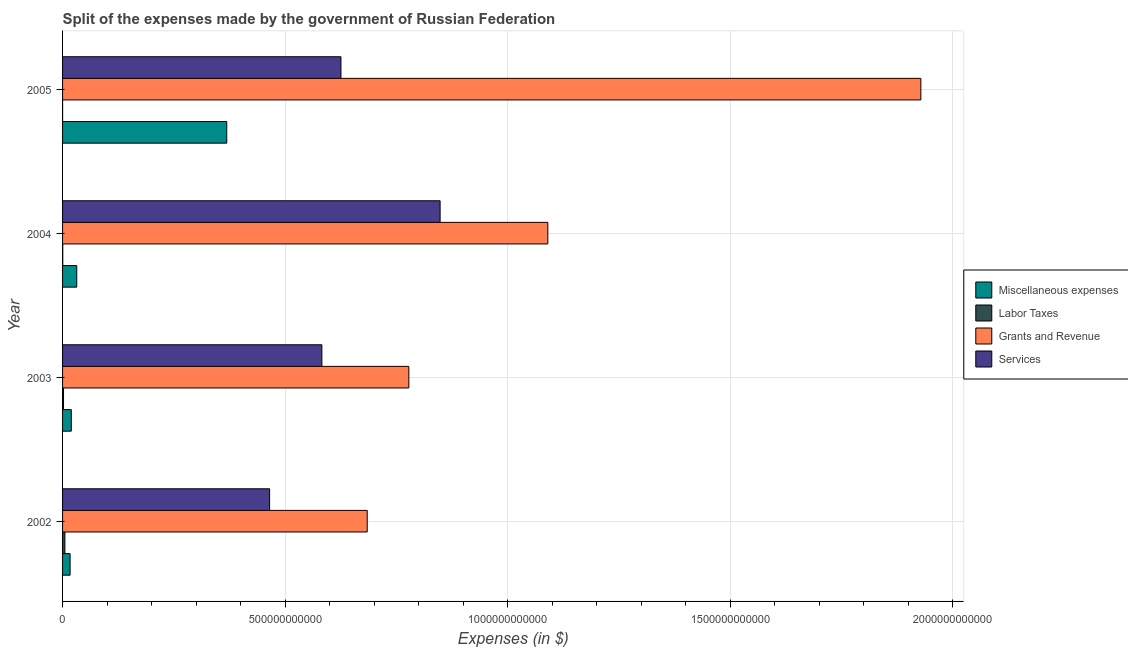How many different coloured bars are there?
Keep it short and to the point. 4. Are the number of bars per tick equal to the number of legend labels?
Your answer should be very brief. Yes. In how many cases, is the number of bars for a given year not equal to the number of legend labels?
Ensure brevity in your answer.  0. What is the amount spent on grants and revenue in 2004?
Offer a very short reply. 1.09e+12. Across all years, what is the maximum amount spent on services?
Provide a succinct answer. 8.48e+11. Across all years, what is the minimum amount spent on miscellaneous expenses?
Offer a very short reply. 1.69e+1. In which year was the amount spent on services maximum?
Provide a succinct answer. 2004. What is the total amount spent on miscellaneous expenses in the graph?
Keep it short and to the point. 4.37e+11. What is the difference between the amount spent on grants and revenue in 2002 and that in 2003?
Keep it short and to the point. -9.35e+1. What is the difference between the amount spent on grants and revenue in 2002 and the amount spent on services in 2005?
Provide a short and direct response. 5.90e+1. What is the average amount spent on miscellaneous expenses per year?
Keep it short and to the point. 1.09e+11. In the year 2002, what is the difference between the amount spent on miscellaneous expenses and amount spent on grants and revenue?
Give a very brief answer. -6.68e+11. In how many years, is the amount spent on labor taxes greater than 1600000000000 $?
Give a very brief answer. 0. What is the ratio of the amount spent on miscellaneous expenses in 2002 to that in 2003?
Ensure brevity in your answer.  0.86. Is the difference between the amount spent on labor taxes in 2002 and 2004 greater than the difference between the amount spent on services in 2002 and 2004?
Keep it short and to the point. Yes. What is the difference between the highest and the second highest amount spent on grants and revenue?
Make the answer very short. 8.38e+11. What is the difference between the highest and the lowest amount spent on services?
Your response must be concise. 3.83e+11. What does the 2nd bar from the top in 2002 represents?
Your response must be concise. Grants and Revenue. What does the 3rd bar from the bottom in 2003 represents?
Give a very brief answer. Grants and Revenue. Is it the case that in every year, the sum of the amount spent on miscellaneous expenses and amount spent on labor taxes is greater than the amount spent on grants and revenue?
Make the answer very short. No. How many bars are there?
Keep it short and to the point. 16. Are all the bars in the graph horizontal?
Make the answer very short. Yes. How many years are there in the graph?
Provide a succinct answer. 4. What is the difference between two consecutive major ticks on the X-axis?
Make the answer very short. 5.00e+11. Are the values on the major ticks of X-axis written in scientific E-notation?
Make the answer very short. No. Does the graph contain grids?
Make the answer very short. Yes. How are the legend labels stacked?
Keep it short and to the point. Vertical. What is the title of the graph?
Offer a very short reply. Split of the expenses made by the government of Russian Federation. Does "Quality of logistic services" appear as one of the legend labels in the graph?
Your answer should be compact. No. What is the label or title of the X-axis?
Ensure brevity in your answer.  Expenses (in $). What is the Expenses (in $) in Miscellaneous expenses in 2002?
Your response must be concise. 1.69e+1. What is the Expenses (in $) in Labor Taxes in 2002?
Your answer should be compact. 5.26e+09. What is the Expenses (in $) in Grants and Revenue in 2002?
Make the answer very short. 6.85e+11. What is the Expenses (in $) of Services in 2002?
Keep it short and to the point. 4.65e+11. What is the Expenses (in $) of Miscellaneous expenses in 2003?
Your answer should be very brief. 1.96e+1. What is the Expenses (in $) in Labor Taxes in 2003?
Your answer should be compact. 2.17e+09. What is the Expenses (in $) of Grants and Revenue in 2003?
Offer a terse response. 7.78e+11. What is the Expenses (in $) in Services in 2003?
Your answer should be very brief. 5.83e+11. What is the Expenses (in $) of Miscellaneous expenses in 2004?
Offer a very short reply. 3.19e+1. What is the Expenses (in $) of Labor Taxes in 2004?
Your response must be concise. 4.01e+08. What is the Expenses (in $) in Grants and Revenue in 2004?
Your response must be concise. 1.09e+12. What is the Expenses (in $) in Services in 2004?
Provide a short and direct response. 8.48e+11. What is the Expenses (in $) of Miscellaneous expenses in 2005?
Your response must be concise. 3.69e+11. What is the Expenses (in $) in Labor Taxes in 2005?
Keep it short and to the point. 7.50e+07. What is the Expenses (in $) in Grants and Revenue in 2005?
Your answer should be compact. 1.93e+12. What is the Expenses (in $) of Services in 2005?
Keep it short and to the point. 6.26e+11. Across all years, what is the maximum Expenses (in $) in Miscellaneous expenses?
Give a very brief answer. 3.69e+11. Across all years, what is the maximum Expenses (in $) of Labor Taxes?
Make the answer very short. 5.26e+09. Across all years, what is the maximum Expenses (in $) in Grants and Revenue?
Make the answer very short. 1.93e+12. Across all years, what is the maximum Expenses (in $) in Services?
Offer a very short reply. 8.48e+11. Across all years, what is the minimum Expenses (in $) of Miscellaneous expenses?
Ensure brevity in your answer.  1.69e+1. Across all years, what is the minimum Expenses (in $) in Labor Taxes?
Offer a very short reply. 7.50e+07. Across all years, what is the minimum Expenses (in $) in Grants and Revenue?
Keep it short and to the point. 6.85e+11. Across all years, what is the minimum Expenses (in $) of Services?
Offer a terse response. 4.65e+11. What is the total Expenses (in $) in Miscellaneous expenses in the graph?
Your answer should be compact. 4.37e+11. What is the total Expenses (in $) of Labor Taxes in the graph?
Give a very brief answer. 7.90e+09. What is the total Expenses (in $) in Grants and Revenue in the graph?
Make the answer very short. 4.48e+12. What is the total Expenses (in $) in Services in the graph?
Your answer should be very brief. 2.52e+12. What is the difference between the Expenses (in $) of Miscellaneous expenses in 2002 and that in 2003?
Offer a terse response. -2.72e+09. What is the difference between the Expenses (in $) in Labor Taxes in 2002 and that in 2003?
Make the answer very short. 3.09e+09. What is the difference between the Expenses (in $) in Grants and Revenue in 2002 and that in 2003?
Your answer should be very brief. -9.35e+1. What is the difference between the Expenses (in $) of Services in 2002 and that in 2003?
Provide a succinct answer. -1.17e+11. What is the difference between the Expenses (in $) of Miscellaneous expenses in 2002 and that in 2004?
Make the answer very short. -1.49e+1. What is the difference between the Expenses (in $) in Labor Taxes in 2002 and that in 2004?
Ensure brevity in your answer.  4.86e+09. What is the difference between the Expenses (in $) in Grants and Revenue in 2002 and that in 2004?
Make the answer very short. -4.06e+11. What is the difference between the Expenses (in $) in Services in 2002 and that in 2004?
Make the answer very short. -3.83e+11. What is the difference between the Expenses (in $) of Miscellaneous expenses in 2002 and that in 2005?
Offer a very short reply. -3.52e+11. What is the difference between the Expenses (in $) of Labor Taxes in 2002 and that in 2005?
Give a very brief answer. 5.18e+09. What is the difference between the Expenses (in $) in Grants and Revenue in 2002 and that in 2005?
Provide a short and direct response. -1.24e+12. What is the difference between the Expenses (in $) of Services in 2002 and that in 2005?
Offer a terse response. -1.60e+11. What is the difference between the Expenses (in $) in Miscellaneous expenses in 2003 and that in 2004?
Your answer should be very brief. -1.22e+1. What is the difference between the Expenses (in $) in Labor Taxes in 2003 and that in 2004?
Keep it short and to the point. 1.77e+09. What is the difference between the Expenses (in $) of Grants and Revenue in 2003 and that in 2004?
Your answer should be compact. -3.12e+11. What is the difference between the Expenses (in $) of Services in 2003 and that in 2004?
Provide a short and direct response. -2.66e+11. What is the difference between the Expenses (in $) of Miscellaneous expenses in 2003 and that in 2005?
Offer a very short reply. -3.49e+11. What is the difference between the Expenses (in $) in Labor Taxes in 2003 and that in 2005?
Ensure brevity in your answer.  2.09e+09. What is the difference between the Expenses (in $) in Grants and Revenue in 2003 and that in 2005?
Provide a succinct answer. -1.15e+12. What is the difference between the Expenses (in $) of Services in 2003 and that in 2005?
Your response must be concise. -4.29e+1. What is the difference between the Expenses (in $) of Miscellaneous expenses in 2004 and that in 2005?
Offer a very short reply. -3.37e+11. What is the difference between the Expenses (in $) of Labor Taxes in 2004 and that in 2005?
Give a very brief answer. 3.26e+08. What is the difference between the Expenses (in $) in Grants and Revenue in 2004 and that in 2005?
Offer a terse response. -8.38e+11. What is the difference between the Expenses (in $) of Services in 2004 and that in 2005?
Offer a terse response. 2.23e+11. What is the difference between the Expenses (in $) of Miscellaneous expenses in 2002 and the Expenses (in $) of Labor Taxes in 2003?
Provide a succinct answer. 1.47e+1. What is the difference between the Expenses (in $) of Miscellaneous expenses in 2002 and the Expenses (in $) of Grants and Revenue in 2003?
Offer a terse response. -7.61e+11. What is the difference between the Expenses (in $) in Miscellaneous expenses in 2002 and the Expenses (in $) in Services in 2003?
Offer a very short reply. -5.66e+11. What is the difference between the Expenses (in $) of Labor Taxes in 2002 and the Expenses (in $) of Grants and Revenue in 2003?
Offer a terse response. -7.73e+11. What is the difference between the Expenses (in $) in Labor Taxes in 2002 and the Expenses (in $) in Services in 2003?
Make the answer very short. -5.77e+11. What is the difference between the Expenses (in $) in Grants and Revenue in 2002 and the Expenses (in $) in Services in 2003?
Provide a short and direct response. 1.02e+11. What is the difference between the Expenses (in $) of Miscellaneous expenses in 2002 and the Expenses (in $) of Labor Taxes in 2004?
Make the answer very short. 1.65e+1. What is the difference between the Expenses (in $) in Miscellaneous expenses in 2002 and the Expenses (in $) in Grants and Revenue in 2004?
Give a very brief answer. -1.07e+12. What is the difference between the Expenses (in $) in Miscellaneous expenses in 2002 and the Expenses (in $) in Services in 2004?
Provide a short and direct response. -8.31e+11. What is the difference between the Expenses (in $) in Labor Taxes in 2002 and the Expenses (in $) in Grants and Revenue in 2004?
Provide a succinct answer. -1.09e+12. What is the difference between the Expenses (in $) of Labor Taxes in 2002 and the Expenses (in $) of Services in 2004?
Your response must be concise. -8.43e+11. What is the difference between the Expenses (in $) in Grants and Revenue in 2002 and the Expenses (in $) in Services in 2004?
Give a very brief answer. -1.64e+11. What is the difference between the Expenses (in $) of Miscellaneous expenses in 2002 and the Expenses (in $) of Labor Taxes in 2005?
Your answer should be very brief. 1.68e+1. What is the difference between the Expenses (in $) of Miscellaneous expenses in 2002 and the Expenses (in $) of Grants and Revenue in 2005?
Your answer should be compact. -1.91e+12. What is the difference between the Expenses (in $) in Miscellaneous expenses in 2002 and the Expenses (in $) in Services in 2005?
Your response must be concise. -6.09e+11. What is the difference between the Expenses (in $) of Labor Taxes in 2002 and the Expenses (in $) of Grants and Revenue in 2005?
Your answer should be compact. -1.92e+12. What is the difference between the Expenses (in $) in Labor Taxes in 2002 and the Expenses (in $) in Services in 2005?
Ensure brevity in your answer.  -6.20e+11. What is the difference between the Expenses (in $) of Grants and Revenue in 2002 and the Expenses (in $) of Services in 2005?
Give a very brief answer. 5.90e+1. What is the difference between the Expenses (in $) in Miscellaneous expenses in 2003 and the Expenses (in $) in Labor Taxes in 2004?
Your response must be concise. 1.92e+1. What is the difference between the Expenses (in $) of Miscellaneous expenses in 2003 and the Expenses (in $) of Grants and Revenue in 2004?
Your response must be concise. -1.07e+12. What is the difference between the Expenses (in $) in Miscellaneous expenses in 2003 and the Expenses (in $) in Services in 2004?
Provide a short and direct response. -8.29e+11. What is the difference between the Expenses (in $) of Labor Taxes in 2003 and the Expenses (in $) of Grants and Revenue in 2004?
Your answer should be compact. -1.09e+12. What is the difference between the Expenses (in $) of Labor Taxes in 2003 and the Expenses (in $) of Services in 2004?
Your answer should be compact. -8.46e+11. What is the difference between the Expenses (in $) in Grants and Revenue in 2003 and the Expenses (in $) in Services in 2004?
Give a very brief answer. -7.03e+1. What is the difference between the Expenses (in $) of Miscellaneous expenses in 2003 and the Expenses (in $) of Labor Taxes in 2005?
Your answer should be compact. 1.96e+1. What is the difference between the Expenses (in $) of Miscellaneous expenses in 2003 and the Expenses (in $) of Grants and Revenue in 2005?
Give a very brief answer. -1.91e+12. What is the difference between the Expenses (in $) in Miscellaneous expenses in 2003 and the Expenses (in $) in Services in 2005?
Your answer should be very brief. -6.06e+11. What is the difference between the Expenses (in $) in Labor Taxes in 2003 and the Expenses (in $) in Grants and Revenue in 2005?
Your answer should be compact. -1.93e+12. What is the difference between the Expenses (in $) of Labor Taxes in 2003 and the Expenses (in $) of Services in 2005?
Keep it short and to the point. -6.23e+11. What is the difference between the Expenses (in $) in Grants and Revenue in 2003 and the Expenses (in $) in Services in 2005?
Provide a succinct answer. 1.53e+11. What is the difference between the Expenses (in $) of Miscellaneous expenses in 2004 and the Expenses (in $) of Labor Taxes in 2005?
Give a very brief answer. 3.18e+1. What is the difference between the Expenses (in $) of Miscellaneous expenses in 2004 and the Expenses (in $) of Grants and Revenue in 2005?
Your response must be concise. -1.90e+12. What is the difference between the Expenses (in $) of Miscellaneous expenses in 2004 and the Expenses (in $) of Services in 2005?
Offer a very short reply. -5.94e+11. What is the difference between the Expenses (in $) of Labor Taxes in 2004 and the Expenses (in $) of Grants and Revenue in 2005?
Your answer should be very brief. -1.93e+12. What is the difference between the Expenses (in $) in Labor Taxes in 2004 and the Expenses (in $) in Services in 2005?
Your answer should be compact. -6.25e+11. What is the difference between the Expenses (in $) in Grants and Revenue in 2004 and the Expenses (in $) in Services in 2005?
Provide a short and direct response. 4.65e+11. What is the average Expenses (in $) in Miscellaneous expenses per year?
Provide a succinct answer. 1.09e+11. What is the average Expenses (in $) in Labor Taxes per year?
Give a very brief answer. 1.97e+09. What is the average Expenses (in $) in Grants and Revenue per year?
Your response must be concise. 1.12e+12. What is the average Expenses (in $) of Services per year?
Ensure brevity in your answer.  6.30e+11. In the year 2002, what is the difference between the Expenses (in $) in Miscellaneous expenses and Expenses (in $) in Labor Taxes?
Keep it short and to the point. 1.17e+1. In the year 2002, what is the difference between the Expenses (in $) of Miscellaneous expenses and Expenses (in $) of Grants and Revenue?
Your response must be concise. -6.68e+11. In the year 2002, what is the difference between the Expenses (in $) of Miscellaneous expenses and Expenses (in $) of Services?
Your answer should be compact. -4.48e+11. In the year 2002, what is the difference between the Expenses (in $) of Labor Taxes and Expenses (in $) of Grants and Revenue?
Offer a very short reply. -6.79e+11. In the year 2002, what is the difference between the Expenses (in $) in Labor Taxes and Expenses (in $) in Services?
Your answer should be compact. -4.60e+11. In the year 2002, what is the difference between the Expenses (in $) in Grants and Revenue and Expenses (in $) in Services?
Make the answer very short. 2.19e+11. In the year 2003, what is the difference between the Expenses (in $) of Miscellaneous expenses and Expenses (in $) of Labor Taxes?
Provide a short and direct response. 1.75e+1. In the year 2003, what is the difference between the Expenses (in $) of Miscellaneous expenses and Expenses (in $) of Grants and Revenue?
Your answer should be compact. -7.58e+11. In the year 2003, what is the difference between the Expenses (in $) of Miscellaneous expenses and Expenses (in $) of Services?
Ensure brevity in your answer.  -5.63e+11. In the year 2003, what is the difference between the Expenses (in $) in Labor Taxes and Expenses (in $) in Grants and Revenue?
Offer a very short reply. -7.76e+11. In the year 2003, what is the difference between the Expenses (in $) in Labor Taxes and Expenses (in $) in Services?
Make the answer very short. -5.81e+11. In the year 2003, what is the difference between the Expenses (in $) of Grants and Revenue and Expenses (in $) of Services?
Ensure brevity in your answer.  1.95e+11. In the year 2004, what is the difference between the Expenses (in $) of Miscellaneous expenses and Expenses (in $) of Labor Taxes?
Offer a terse response. 3.15e+1. In the year 2004, what is the difference between the Expenses (in $) in Miscellaneous expenses and Expenses (in $) in Grants and Revenue?
Your response must be concise. -1.06e+12. In the year 2004, what is the difference between the Expenses (in $) of Miscellaneous expenses and Expenses (in $) of Services?
Keep it short and to the point. -8.16e+11. In the year 2004, what is the difference between the Expenses (in $) of Labor Taxes and Expenses (in $) of Grants and Revenue?
Provide a short and direct response. -1.09e+12. In the year 2004, what is the difference between the Expenses (in $) of Labor Taxes and Expenses (in $) of Services?
Ensure brevity in your answer.  -8.48e+11. In the year 2004, what is the difference between the Expenses (in $) in Grants and Revenue and Expenses (in $) in Services?
Keep it short and to the point. 2.42e+11. In the year 2005, what is the difference between the Expenses (in $) of Miscellaneous expenses and Expenses (in $) of Labor Taxes?
Provide a succinct answer. 3.69e+11. In the year 2005, what is the difference between the Expenses (in $) of Miscellaneous expenses and Expenses (in $) of Grants and Revenue?
Provide a succinct answer. -1.56e+12. In the year 2005, what is the difference between the Expenses (in $) in Miscellaneous expenses and Expenses (in $) in Services?
Ensure brevity in your answer.  -2.57e+11. In the year 2005, what is the difference between the Expenses (in $) in Labor Taxes and Expenses (in $) in Grants and Revenue?
Provide a short and direct response. -1.93e+12. In the year 2005, what is the difference between the Expenses (in $) of Labor Taxes and Expenses (in $) of Services?
Your answer should be very brief. -6.25e+11. In the year 2005, what is the difference between the Expenses (in $) in Grants and Revenue and Expenses (in $) in Services?
Your response must be concise. 1.30e+12. What is the ratio of the Expenses (in $) of Miscellaneous expenses in 2002 to that in 2003?
Keep it short and to the point. 0.86. What is the ratio of the Expenses (in $) in Labor Taxes in 2002 to that in 2003?
Keep it short and to the point. 2.43. What is the ratio of the Expenses (in $) of Grants and Revenue in 2002 to that in 2003?
Your response must be concise. 0.88. What is the ratio of the Expenses (in $) in Services in 2002 to that in 2003?
Offer a terse response. 0.8. What is the ratio of the Expenses (in $) of Miscellaneous expenses in 2002 to that in 2004?
Give a very brief answer. 0.53. What is the ratio of the Expenses (in $) in Labor Taxes in 2002 to that in 2004?
Provide a succinct answer. 13.12. What is the ratio of the Expenses (in $) in Grants and Revenue in 2002 to that in 2004?
Your answer should be very brief. 0.63. What is the ratio of the Expenses (in $) of Services in 2002 to that in 2004?
Make the answer very short. 0.55. What is the ratio of the Expenses (in $) of Miscellaneous expenses in 2002 to that in 2005?
Offer a terse response. 0.05. What is the ratio of the Expenses (in $) of Labor Taxes in 2002 to that in 2005?
Provide a succinct answer. 70.11. What is the ratio of the Expenses (in $) in Grants and Revenue in 2002 to that in 2005?
Keep it short and to the point. 0.35. What is the ratio of the Expenses (in $) in Services in 2002 to that in 2005?
Keep it short and to the point. 0.74. What is the ratio of the Expenses (in $) of Miscellaneous expenses in 2003 to that in 2004?
Your answer should be very brief. 0.62. What is the ratio of the Expenses (in $) in Labor Taxes in 2003 to that in 2004?
Your answer should be compact. 5.41. What is the ratio of the Expenses (in $) of Grants and Revenue in 2003 to that in 2004?
Offer a very short reply. 0.71. What is the ratio of the Expenses (in $) in Services in 2003 to that in 2004?
Provide a short and direct response. 0.69. What is the ratio of the Expenses (in $) in Miscellaneous expenses in 2003 to that in 2005?
Provide a short and direct response. 0.05. What is the ratio of the Expenses (in $) in Labor Taxes in 2003 to that in 2005?
Keep it short and to the point. 28.88. What is the ratio of the Expenses (in $) in Grants and Revenue in 2003 to that in 2005?
Provide a short and direct response. 0.4. What is the ratio of the Expenses (in $) in Services in 2003 to that in 2005?
Make the answer very short. 0.93. What is the ratio of the Expenses (in $) in Miscellaneous expenses in 2004 to that in 2005?
Keep it short and to the point. 0.09. What is the ratio of the Expenses (in $) in Labor Taxes in 2004 to that in 2005?
Give a very brief answer. 5.34. What is the ratio of the Expenses (in $) of Grants and Revenue in 2004 to that in 2005?
Provide a short and direct response. 0.57. What is the ratio of the Expenses (in $) in Services in 2004 to that in 2005?
Give a very brief answer. 1.36. What is the difference between the highest and the second highest Expenses (in $) in Miscellaneous expenses?
Your response must be concise. 3.37e+11. What is the difference between the highest and the second highest Expenses (in $) of Labor Taxes?
Your answer should be compact. 3.09e+09. What is the difference between the highest and the second highest Expenses (in $) of Grants and Revenue?
Your answer should be very brief. 8.38e+11. What is the difference between the highest and the second highest Expenses (in $) of Services?
Make the answer very short. 2.23e+11. What is the difference between the highest and the lowest Expenses (in $) in Miscellaneous expenses?
Offer a terse response. 3.52e+11. What is the difference between the highest and the lowest Expenses (in $) in Labor Taxes?
Your answer should be very brief. 5.18e+09. What is the difference between the highest and the lowest Expenses (in $) in Grants and Revenue?
Provide a succinct answer. 1.24e+12. What is the difference between the highest and the lowest Expenses (in $) in Services?
Your answer should be very brief. 3.83e+11. 